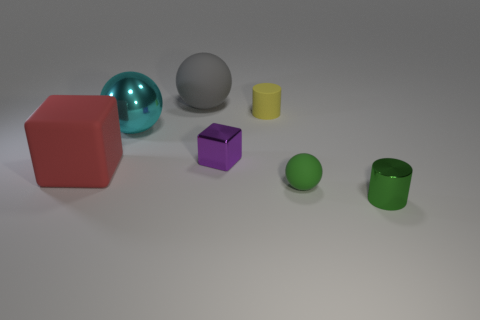Add 1 tiny cyan shiny balls. How many objects exist? 8 Subtract all blocks. How many objects are left? 5 Add 6 tiny yellow matte cylinders. How many tiny yellow matte cylinders exist? 7 Subtract 0 yellow blocks. How many objects are left? 7 Subtract all green shiny cylinders. Subtract all green objects. How many objects are left? 4 Add 7 red matte objects. How many red matte objects are left? 8 